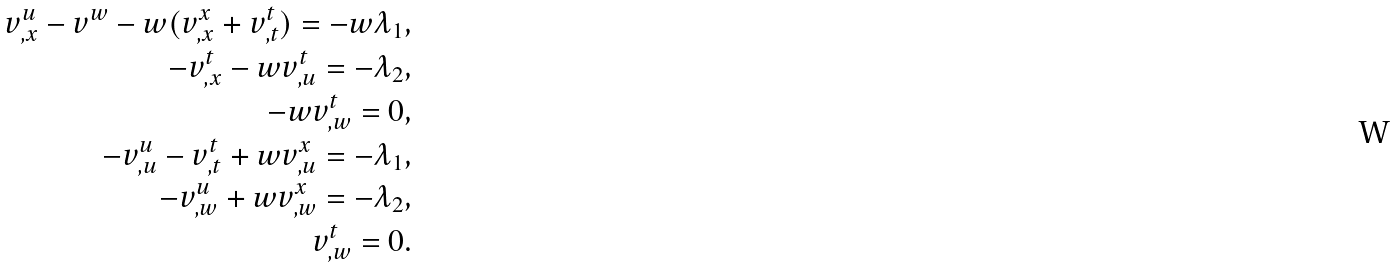Convert formula to latex. <formula><loc_0><loc_0><loc_500><loc_500>v ^ { u } _ { , x } - v ^ { w } - w ( v ^ { x } _ { , x } + v ^ { t } _ { , t } ) = - w \lambda _ { 1 } , \\ - v ^ { t } _ { , x } - w v ^ { t } _ { , u } = - \lambda _ { 2 } , \\ - w v ^ { t } _ { , w } = 0 , \\ - v ^ { u } _ { , u } - v ^ { t } _ { , t } + w v ^ { x } _ { , u } = - \lambda _ { 1 } , \\ - v ^ { u } _ { , w } + w v ^ { x } _ { , w } = - \lambda _ { 2 } , \\ v ^ { t } _ { , w } = 0 .</formula> 